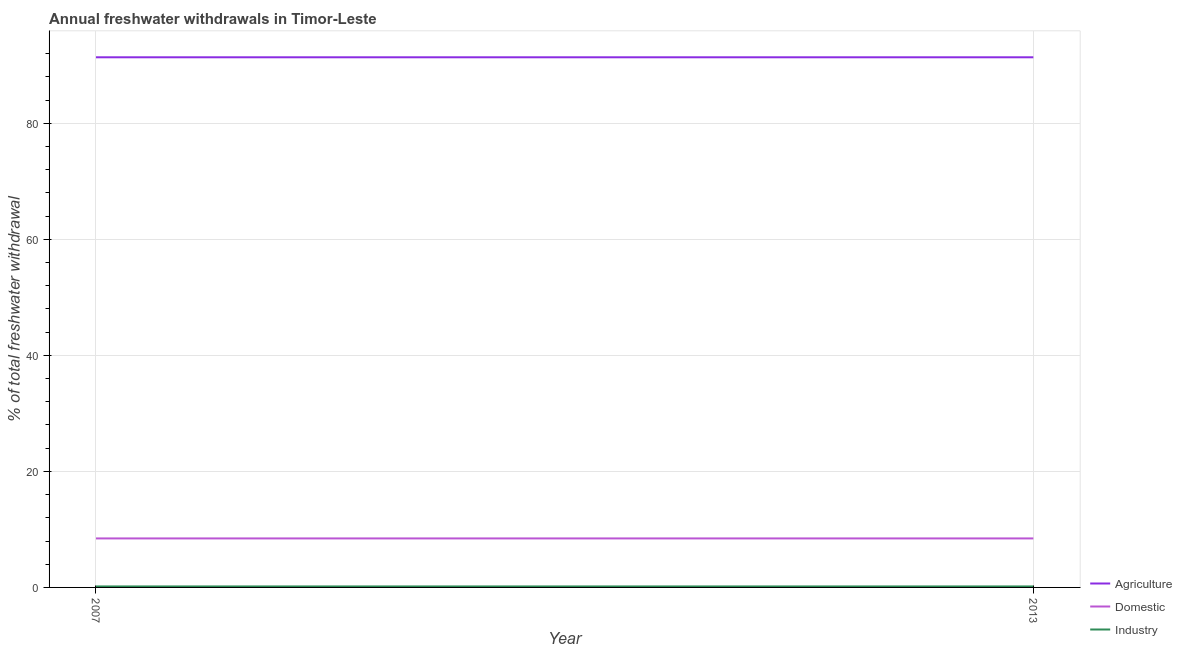How many different coloured lines are there?
Your answer should be very brief. 3. What is the percentage of freshwater withdrawal for domestic purposes in 2007?
Keep it short and to the point. 8.45. Across all years, what is the maximum percentage of freshwater withdrawal for domestic purposes?
Your answer should be compact. 8.45. Across all years, what is the minimum percentage of freshwater withdrawal for industry?
Your answer should be very brief. 0.17. What is the total percentage of freshwater withdrawal for industry in the graph?
Give a very brief answer. 0.34. What is the difference between the percentage of freshwater withdrawal for agriculture in 2007 and that in 2013?
Your response must be concise. 0. What is the difference between the percentage of freshwater withdrawal for agriculture in 2013 and the percentage of freshwater withdrawal for domestic purposes in 2007?
Ensure brevity in your answer.  82.93. What is the average percentage of freshwater withdrawal for industry per year?
Provide a succinct answer. 0.17. In the year 2007, what is the difference between the percentage of freshwater withdrawal for domestic purposes and percentage of freshwater withdrawal for industry?
Keep it short and to the point. 8.28. Does the percentage of freshwater withdrawal for industry monotonically increase over the years?
Your answer should be very brief. No. How many lines are there?
Offer a terse response. 3. Does the graph contain any zero values?
Give a very brief answer. No. How are the legend labels stacked?
Your answer should be compact. Vertical. What is the title of the graph?
Make the answer very short. Annual freshwater withdrawals in Timor-Leste. Does "Natural gas sources" appear as one of the legend labels in the graph?
Keep it short and to the point. No. What is the label or title of the Y-axis?
Provide a succinct answer. % of total freshwater withdrawal. What is the % of total freshwater withdrawal in Agriculture in 2007?
Offer a terse response. 91.38. What is the % of total freshwater withdrawal in Domestic in 2007?
Keep it short and to the point. 8.45. What is the % of total freshwater withdrawal in Industry in 2007?
Your answer should be compact. 0.17. What is the % of total freshwater withdrawal of Agriculture in 2013?
Make the answer very short. 91.38. What is the % of total freshwater withdrawal of Domestic in 2013?
Offer a very short reply. 8.45. What is the % of total freshwater withdrawal in Industry in 2013?
Keep it short and to the point. 0.17. Across all years, what is the maximum % of total freshwater withdrawal in Agriculture?
Make the answer very short. 91.38. Across all years, what is the maximum % of total freshwater withdrawal in Domestic?
Offer a terse response. 8.45. Across all years, what is the maximum % of total freshwater withdrawal of Industry?
Keep it short and to the point. 0.17. Across all years, what is the minimum % of total freshwater withdrawal of Agriculture?
Offer a terse response. 91.38. Across all years, what is the minimum % of total freshwater withdrawal in Domestic?
Offer a terse response. 8.45. Across all years, what is the minimum % of total freshwater withdrawal of Industry?
Make the answer very short. 0.17. What is the total % of total freshwater withdrawal in Agriculture in the graph?
Ensure brevity in your answer.  182.76. What is the total % of total freshwater withdrawal of Domestic in the graph?
Provide a succinct answer. 16.89. What is the total % of total freshwater withdrawal of Industry in the graph?
Give a very brief answer. 0.34. What is the difference between the % of total freshwater withdrawal of Agriculture in 2007 and the % of total freshwater withdrawal of Domestic in 2013?
Offer a terse response. 82.93. What is the difference between the % of total freshwater withdrawal in Agriculture in 2007 and the % of total freshwater withdrawal in Industry in 2013?
Your response must be concise. 91.21. What is the difference between the % of total freshwater withdrawal of Domestic in 2007 and the % of total freshwater withdrawal of Industry in 2013?
Provide a short and direct response. 8.28. What is the average % of total freshwater withdrawal in Agriculture per year?
Your answer should be very brief. 91.38. What is the average % of total freshwater withdrawal of Domestic per year?
Offer a terse response. 8.45. What is the average % of total freshwater withdrawal in Industry per year?
Your answer should be compact. 0.17. In the year 2007, what is the difference between the % of total freshwater withdrawal in Agriculture and % of total freshwater withdrawal in Domestic?
Your response must be concise. 82.93. In the year 2007, what is the difference between the % of total freshwater withdrawal in Agriculture and % of total freshwater withdrawal in Industry?
Your answer should be compact. 91.21. In the year 2007, what is the difference between the % of total freshwater withdrawal in Domestic and % of total freshwater withdrawal in Industry?
Offer a terse response. 8.28. In the year 2013, what is the difference between the % of total freshwater withdrawal of Agriculture and % of total freshwater withdrawal of Domestic?
Your answer should be compact. 82.93. In the year 2013, what is the difference between the % of total freshwater withdrawal of Agriculture and % of total freshwater withdrawal of Industry?
Your answer should be compact. 91.21. In the year 2013, what is the difference between the % of total freshwater withdrawal in Domestic and % of total freshwater withdrawal in Industry?
Your response must be concise. 8.28. What is the ratio of the % of total freshwater withdrawal in Agriculture in 2007 to that in 2013?
Keep it short and to the point. 1. What is the ratio of the % of total freshwater withdrawal of Domestic in 2007 to that in 2013?
Your answer should be compact. 1. What is the ratio of the % of total freshwater withdrawal of Industry in 2007 to that in 2013?
Your answer should be very brief. 1. What is the difference between the highest and the second highest % of total freshwater withdrawal in Agriculture?
Offer a terse response. 0. What is the difference between the highest and the second highest % of total freshwater withdrawal of Domestic?
Give a very brief answer. 0. What is the difference between the highest and the lowest % of total freshwater withdrawal of Domestic?
Provide a short and direct response. 0. What is the difference between the highest and the lowest % of total freshwater withdrawal of Industry?
Give a very brief answer. 0. 